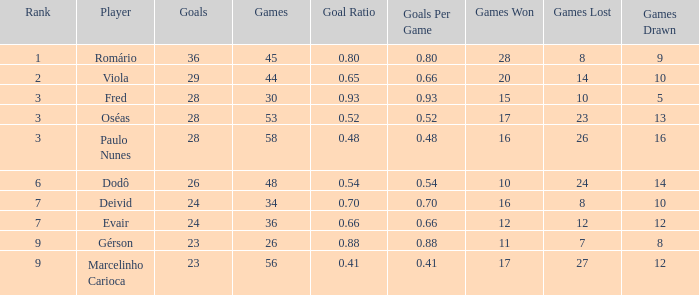What is the largest value for goals in rank over 3 with goal ration of 0.54? 26.0. 